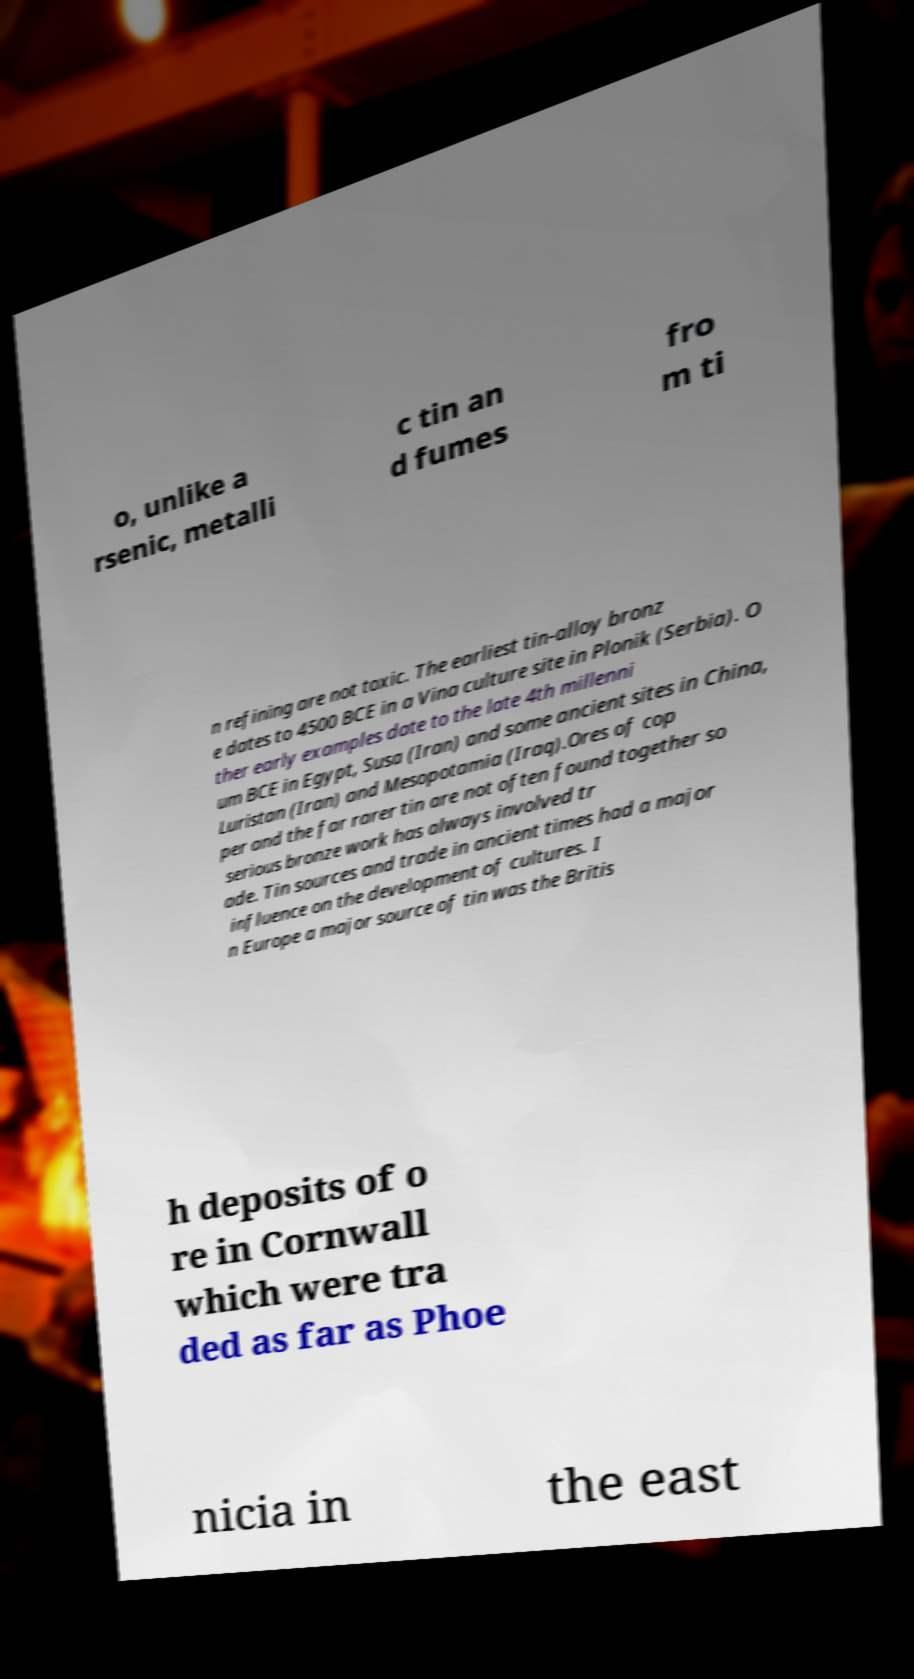Can you read and provide the text displayed in the image?This photo seems to have some interesting text. Can you extract and type it out for me? o, unlike a rsenic, metalli c tin an d fumes fro m ti n refining are not toxic. The earliest tin-alloy bronz e dates to 4500 BCE in a Vina culture site in Plonik (Serbia). O ther early examples date to the late 4th millenni um BCE in Egypt, Susa (Iran) and some ancient sites in China, Luristan (Iran) and Mesopotamia (Iraq).Ores of cop per and the far rarer tin are not often found together so serious bronze work has always involved tr ade. Tin sources and trade in ancient times had a major influence on the development of cultures. I n Europe a major source of tin was the Britis h deposits of o re in Cornwall which were tra ded as far as Phoe nicia in the east 